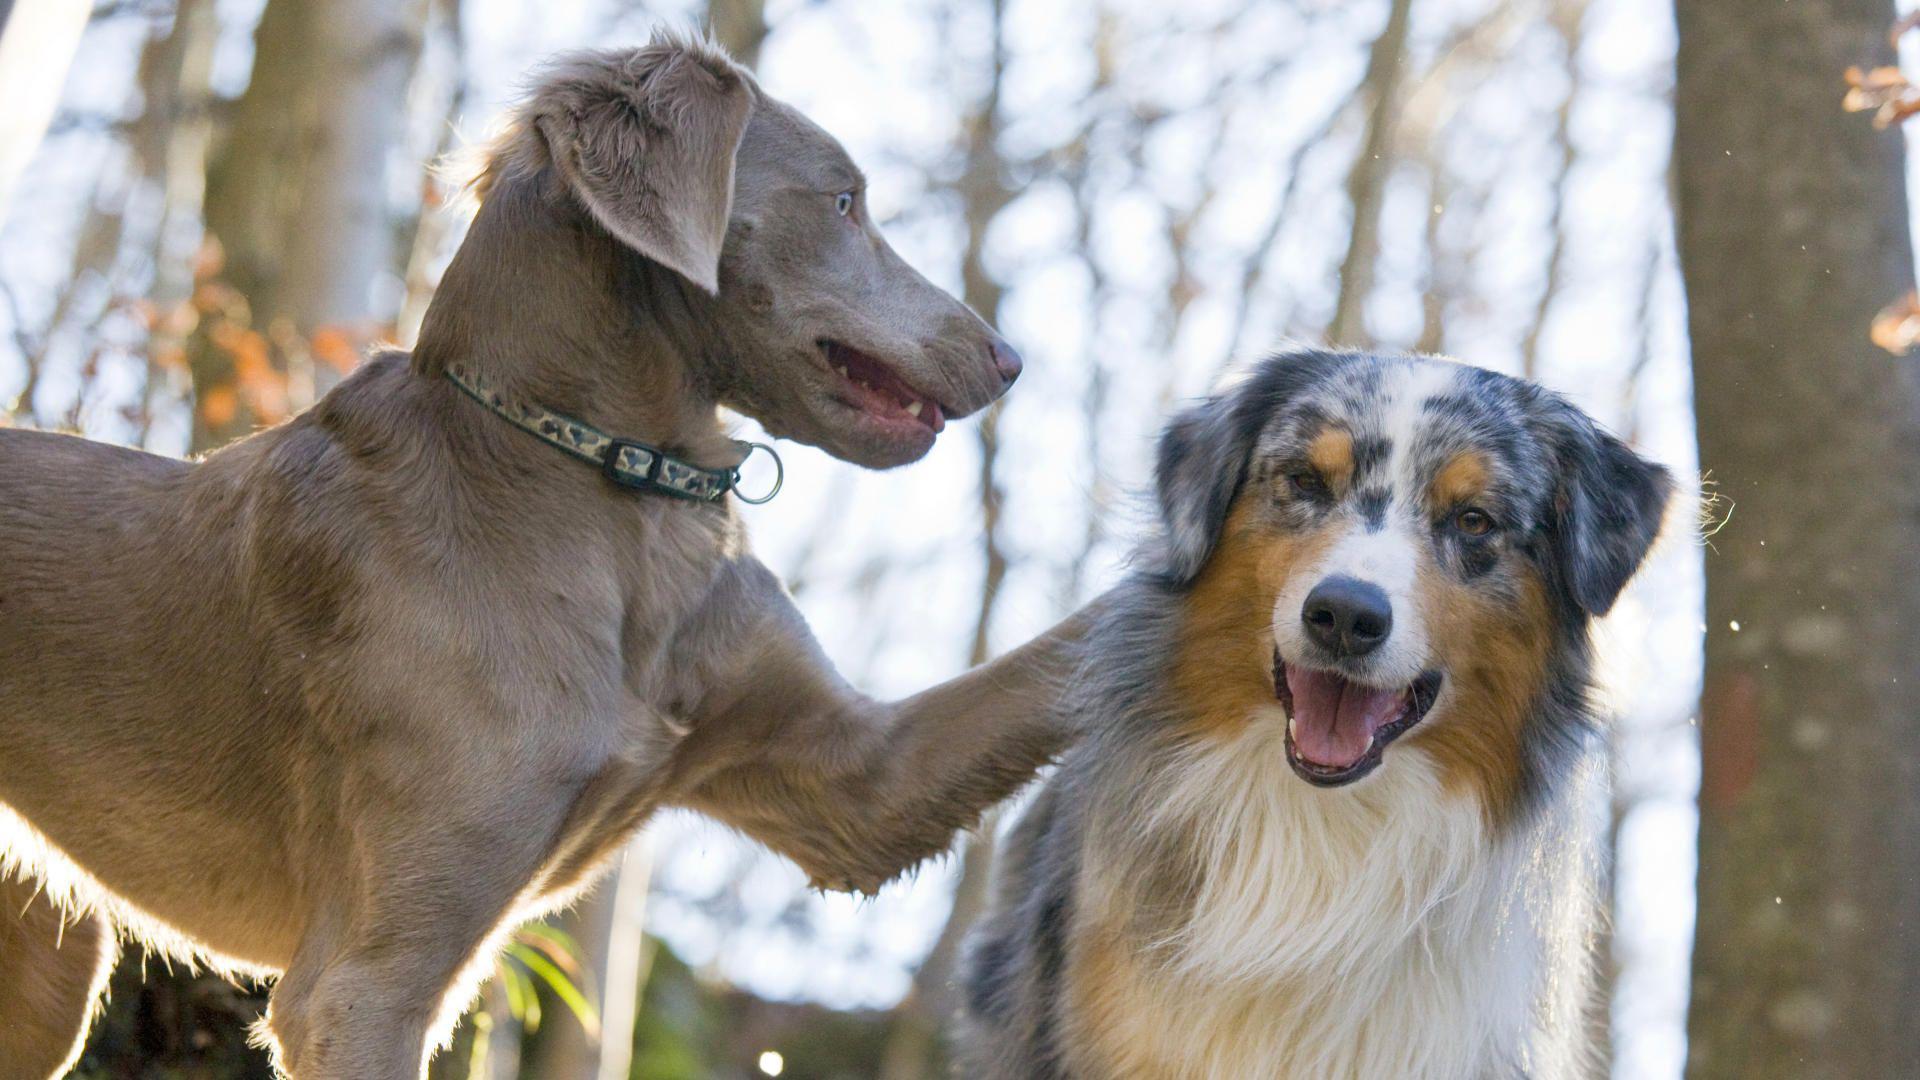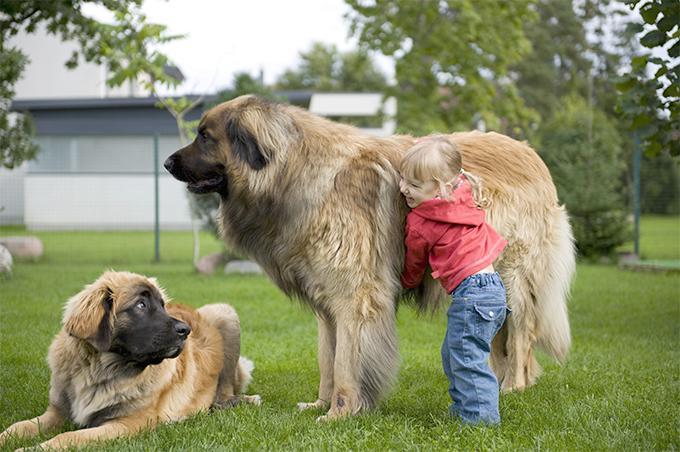The first image is the image on the left, the second image is the image on the right. Considering the images on both sides, is "An image shows a toddler girl next to a large dog." valid? Answer yes or no. Yes. 